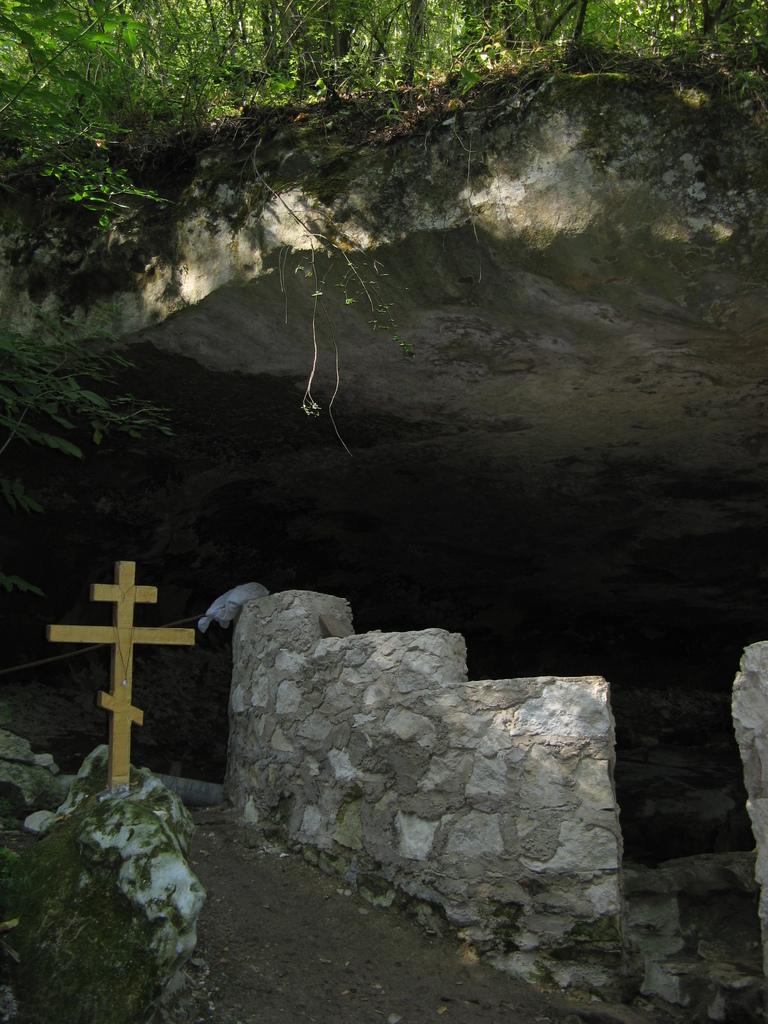In one or two sentences, can you explain what this image depicts? In this picture we can see a holly cross symbol. On the right side of the holly cross symbol, there is a wall. At the top of the image, there are trees. 